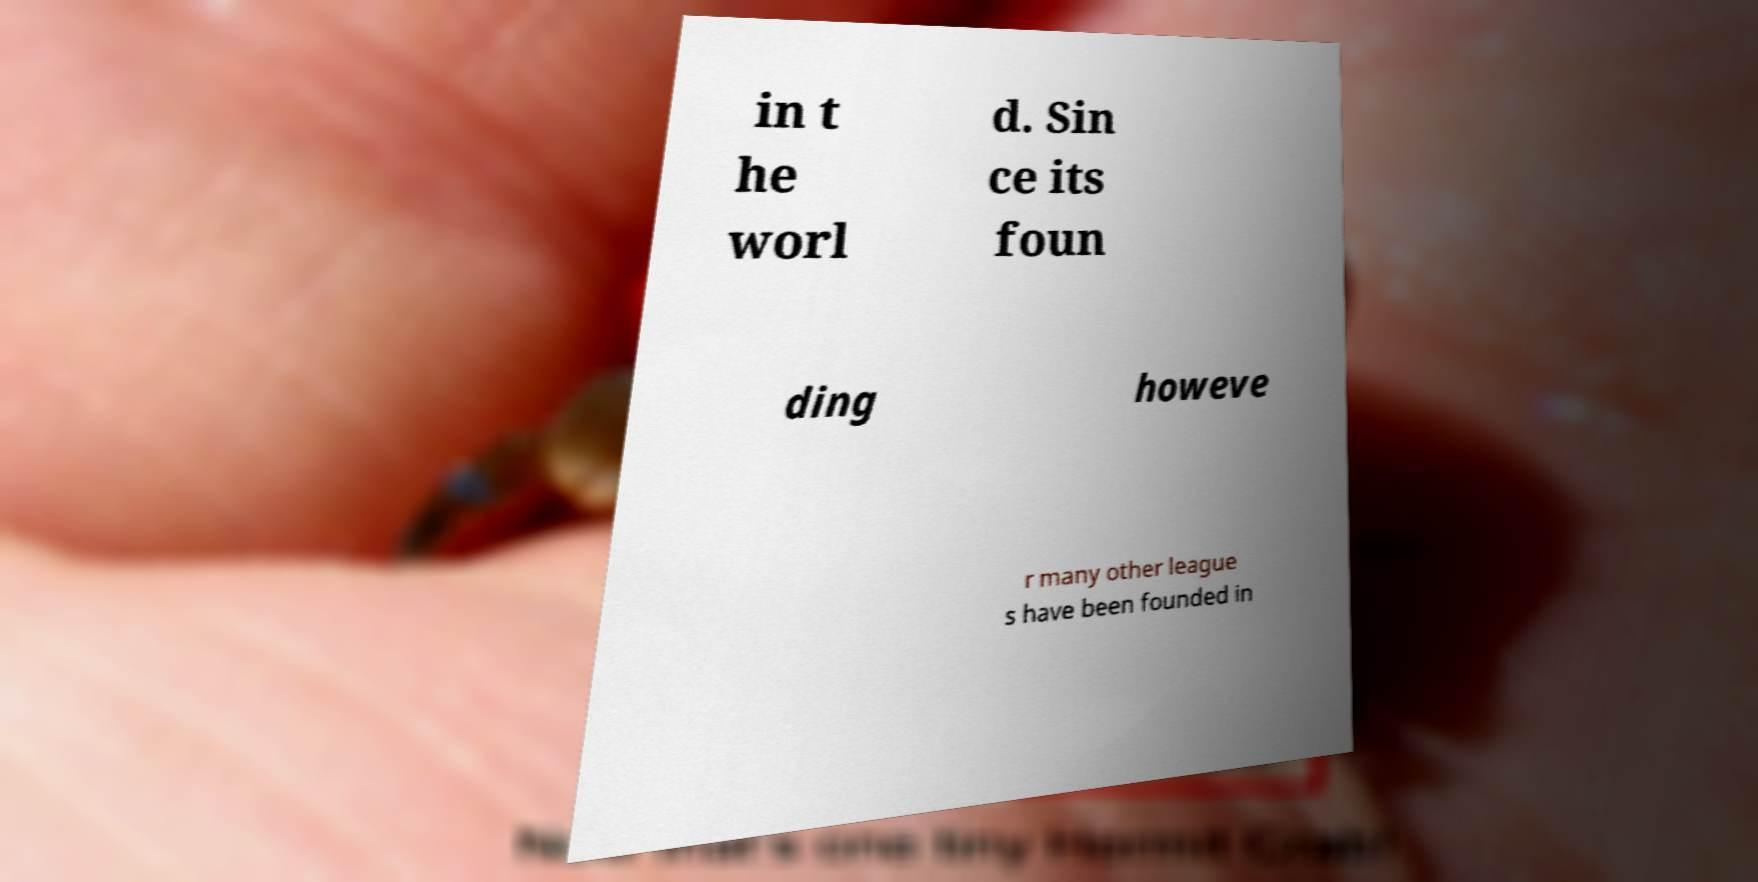Please read and relay the text visible in this image. What does it say? in t he worl d. Sin ce its foun ding howeve r many other league s have been founded in 